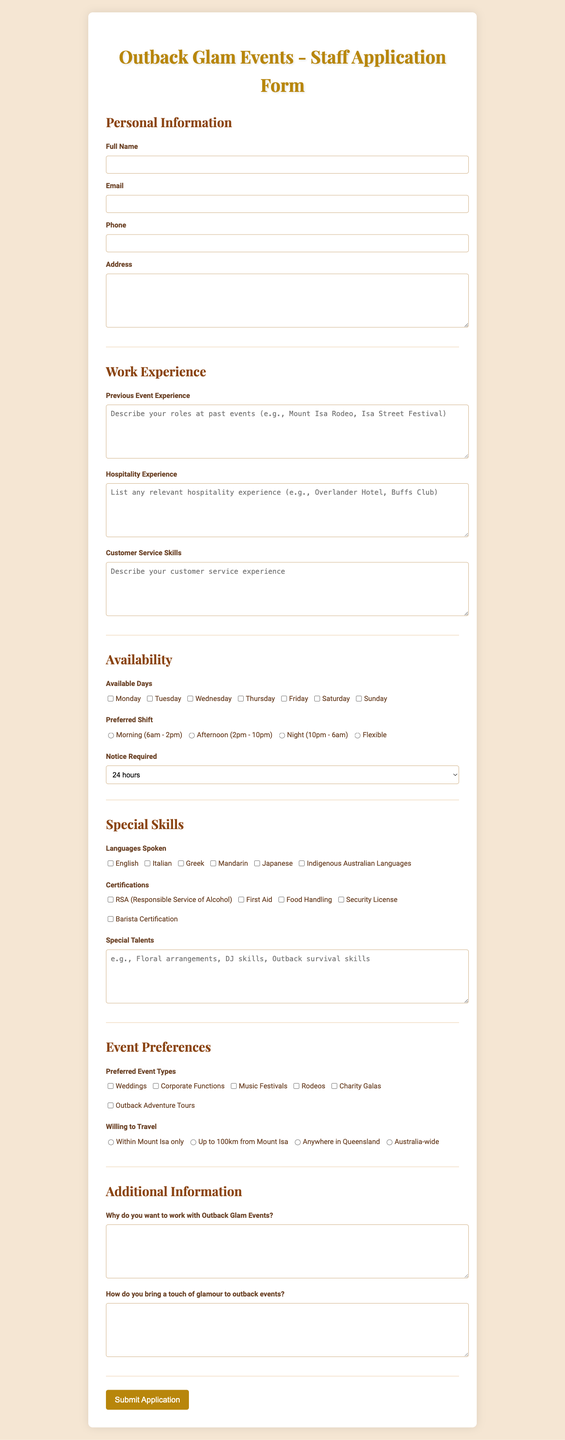what is the title of the form? The title of the form is mentioned at the top of the document.
Answer: Outback Glam Events - Staff Application Form how many sections are in the form? The form is divided into multiple sections, each focusing on different areas of information.
Answer: 7 what is the placeholder text for previous event experience? The placeholder text provides guidance on what to include for this field.
Answer: Describe your roles at past events (e.g., Mount Isa Rodeo, Isa Street Festival) which shift option is flexible? This refers to the shift timing options provided in the availability section.
Answer: Flexible what is the maximum notice required before starting work? This is a specific option listed under the availability section.
Answer: 2 weeks how many languages can be selected in the languages spoken section? The number of options provided suggests the variety of languages applicants can indicate.
Answer: 6 what types of events are preferred according to the form? This refers to the options provided in the event preferences section.
Answer: Weddings, Corporate Functions, Music Festivals, Rodeos, Charity Galas, Outback Adventure Tours what is the requirement for customer service skills? The document specifies the content that applicants should describe in this field.
Answer: Describe your customer service experience why is the certification section important? This section highlights qualifications that could enhance the applicant's skills for events.
Answer: To assess additional skills relevant to the job 